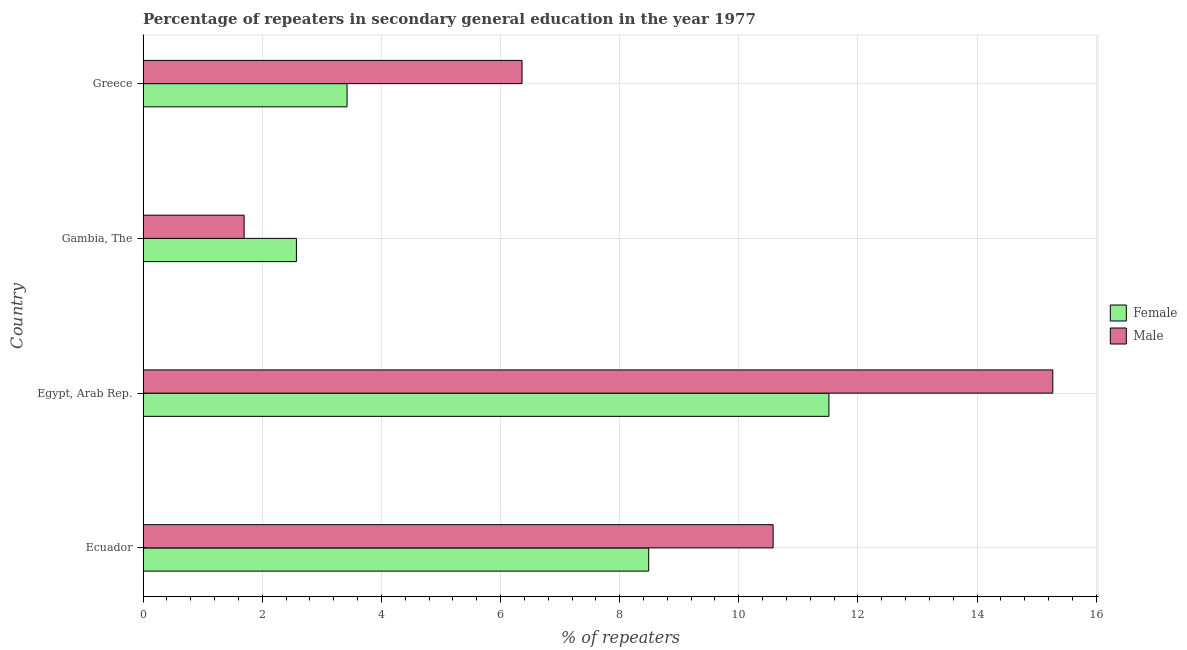How many groups of bars are there?
Offer a terse response. 4. Are the number of bars on each tick of the Y-axis equal?
Ensure brevity in your answer.  Yes. How many bars are there on the 1st tick from the bottom?
Give a very brief answer. 2. What is the label of the 2nd group of bars from the top?
Your response must be concise. Gambia, The. In how many cases, is the number of bars for a given country not equal to the number of legend labels?
Your answer should be compact. 0. What is the percentage of male repeaters in Ecuador?
Your response must be concise. 10.58. Across all countries, what is the maximum percentage of female repeaters?
Offer a very short reply. 11.51. Across all countries, what is the minimum percentage of male repeaters?
Your answer should be very brief. 1.7. In which country was the percentage of female repeaters maximum?
Your response must be concise. Egypt, Arab Rep. In which country was the percentage of male repeaters minimum?
Give a very brief answer. Gambia, The. What is the total percentage of female repeaters in the graph?
Make the answer very short. 26. What is the difference between the percentage of male repeaters in Gambia, The and that in Greece?
Your answer should be compact. -4.67. What is the difference between the percentage of female repeaters in Egypt, Arab Rep. and the percentage of male repeaters in Greece?
Provide a short and direct response. 5.15. What is the average percentage of male repeaters per country?
Keep it short and to the point. 8.48. What is the difference between the percentage of male repeaters and percentage of female repeaters in Greece?
Provide a short and direct response. 2.94. In how many countries, is the percentage of male repeaters greater than 2 %?
Your response must be concise. 3. What is the ratio of the percentage of male repeaters in Egypt, Arab Rep. to that in Gambia, The?
Your answer should be very brief. 9. Is the percentage of male repeaters in Egypt, Arab Rep. less than that in Greece?
Your answer should be compact. No. What is the difference between the highest and the second highest percentage of male repeaters?
Provide a short and direct response. 4.7. What is the difference between the highest and the lowest percentage of male repeaters?
Give a very brief answer. 13.57. In how many countries, is the percentage of female repeaters greater than the average percentage of female repeaters taken over all countries?
Ensure brevity in your answer.  2. Are all the bars in the graph horizontal?
Give a very brief answer. Yes. What is the difference between two consecutive major ticks on the X-axis?
Provide a succinct answer. 2. Does the graph contain grids?
Give a very brief answer. Yes. Where does the legend appear in the graph?
Make the answer very short. Center right. How many legend labels are there?
Ensure brevity in your answer.  2. What is the title of the graph?
Make the answer very short. Percentage of repeaters in secondary general education in the year 1977. What is the label or title of the X-axis?
Ensure brevity in your answer.  % of repeaters. What is the % of repeaters in Female in Ecuador?
Make the answer very short. 8.49. What is the % of repeaters in Male in Ecuador?
Ensure brevity in your answer.  10.58. What is the % of repeaters in Female in Egypt, Arab Rep.?
Offer a terse response. 11.51. What is the % of repeaters in Male in Egypt, Arab Rep.?
Offer a terse response. 15.27. What is the % of repeaters in Female in Gambia, The?
Your response must be concise. 2.57. What is the % of repeaters of Male in Gambia, The?
Offer a very short reply. 1.7. What is the % of repeaters of Female in Greece?
Offer a terse response. 3.42. What is the % of repeaters in Male in Greece?
Make the answer very short. 6.36. Across all countries, what is the maximum % of repeaters in Female?
Your answer should be compact. 11.51. Across all countries, what is the maximum % of repeaters in Male?
Offer a very short reply. 15.27. Across all countries, what is the minimum % of repeaters in Female?
Your answer should be compact. 2.57. Across all countries, what is the minimum % of repeaters of Male?
Provide a short and direct response. 1.7. What is the total % of repeaters of Female in the graph?
Your answer should be very brief. 26. What is the total % of repeaters in Male in the graph?
Provide a short and direct response. 33.91. What is the difference between the % of repeaters of Female in Ecuador and that in Egypt, Arab Rep.?
Make the answer very short. -3.03. What is the difference between the % of repeaters in Male in Ecuador and that in Egypt, Arab Rep.?
Offer a very short reply. -4.69. What is the difference between the % of repeaters of Female in Ecuador and that in Gambia, The?
Provide a short and direct response. 5.91. What is the difference between the % of repeaters of Male in Ecuador and that in Gambia, The?
Provide a short and direct response. 8.88. What is the difference between the % of repeaters in Female in Ecuador and that in Greece?
Keep it short and to the point. 5.06. What is the difference between the % of repeaters in Male in Ecuador and that in Greece?
Your answer should be compact. 4.21. What is the difference between the % of repeaters in Female in Egypt, Arab Rep. and that in Gambia, The?
Offer a very short reply. 8.94. What is the difference between the % of repeaters in Male in Egypt, Arab Rep. and that in Gambia, The?
Make the answer very short. 13.57. What is the difference between the % of repeaters of Female in Egypt, Arab Rep. and that in Greece?
Keep it short and to the point. 8.09. What is the difference between the % of repeaters of Male in Egypt, Arab Rep. and that in Greece?
Offer a very short reply. 8.91. What is the difference between the % of repeaters of Female in Gambia, The and that in Greece?
Your answer should be very brief. -0.85. What is the difference between the % of repeaters in Male in Gambia, The and that in Greece?
Your response must be concise. -4.67. What is the difference between the % of repeaters of Female in Ecuador and the % of repeaters of Male in Egypt, Arab Rep.?
Your response must be concise. -6.78. What is the difference between the % of repeaters in Female in Ecuador and the % of repeaters in Male in Gambia, The?
Offer a terse response. 6.79. What is the difference between the % of repeaters of Female in Ecuador and the % of repeaters of Male in Greece?
Offer a terse response. 2.13. What is the difference between the % of repeaters in Female in Egypt, Arab Rep. and the % of repeaters in Male in Gambia, The?
Your answer should be very brief. 9.82. What is the difference between the % of repeaters in Female in Egypt, Arab Rep. and the % of repeaters in Male in Greece?
Your response must be concise. 5.15. What is the difference between the % of repeaters in Female in Gambia, The and the % of repeaters in Male in Greece?
Your response must be concise. -3.79. What is the average % of repeaters of Female per country?
Give a very brief answer. 6.5. What is the average % of repeaters in Male per country?
Ensure brevity in your answer.  8.48. What is the difference between the % of repeaters in Female and % of repeaters in Male in Ecuador?
Your answer should be compact. -2.09. What is the difference between the % of repeaters of Female and % of repeaters of Male in Egypt, Arab Rep.?
Offer a terse response. -3.76. What is the difference between the % of repeaters in Female and % of repeaters in Male in Gambia, The?
Offer a very short reply. 0.88. What is the difference between the % of repeaters of Female and % of repeaters of Male in Greece?
Make the answer very short. -2.94. What is the ratio of the % of repeaters of Female in Ecuador to that in Egypt, Arab Rep.?
Offer a terse response. 0.74. What is the ratio of the % of repeaters in Male in Ecuador to that in Egypt, Arab Rep.?
Ensure brevity in your answer.  0.69. What is the ratio of the % of repeaters of Female in Ecuador to that in Gambia, The?
Offer a terse response. 3.3. What is the ratio of the % of repeaters of Male in Ecuador to that in Gambia, The?
Your answer should be compact. 6.23. What is the ratio of the % of repeaters in Female in Ecuador to that in Greece?
Offer a very short reply. 2.48. What is the ratio of the % of repeaters in Male in Ecuador to that in Greece?
Your answer should be very brief. 1.66. What is the ratio of the % of repeaters in Female in Egypt, Arab Rep. to that in Gambia, The?
Your answer should be compact. 4.47. What is the ratio of the % of repeaters of Male in Egypt, Arab Rep. to that in Gambia, The?
Provide a succinct answer. 9. What is the ratio of the % of repeaters in Female in Egypt, Arab Rep. to that in Greece?
Make the answer very short. 3.36. What is the ratio of the % of repeaters of Male in Egypt, Arab Rep. to that in Greece?
Provide a succinct answer. 2.4. What is the ratio of the % of repeaters of Female in Gambia, The to that in Greece?
Your answer should be compact. 0.75. What is the ratio of the % of repeaters in Male in Gambia, The to that in Greece?
Provide a succinct answer. 0.27. What is the difference between the highest and the second highest % of repeaters of Female?
Your answer should be compact. 3.03. What is the difference between the highest and the second highest % of repeaters of Male?
Make the answer very short. 4.69. What is the difference between the highest and the lowest % of repeaters of Female?
Your answer should be very brief. 8.94. What is the difference between the highest and the lowest % of repeaters of Male?
Offer a terse response. 13.57. 